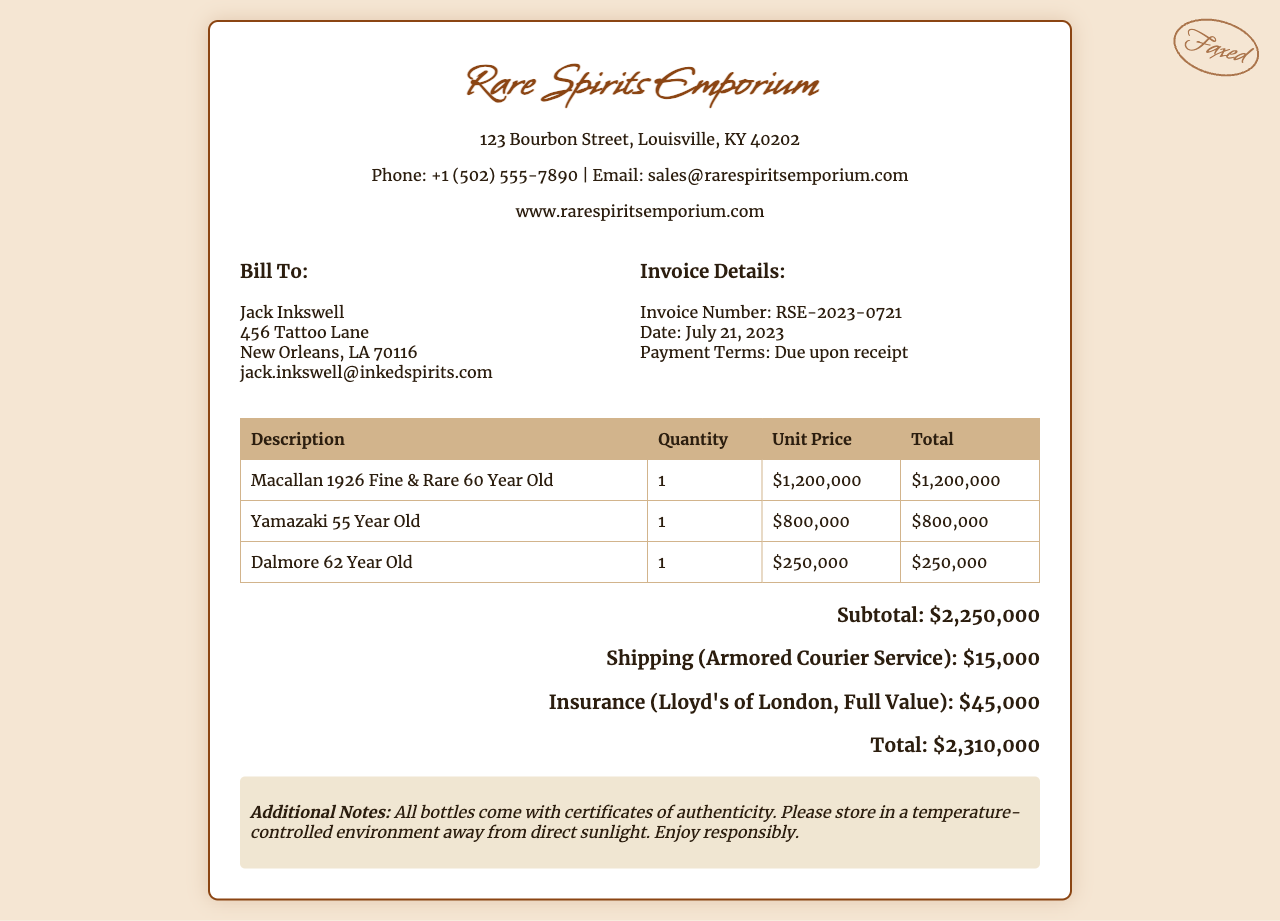What is the company name? The company name is prominently stated at the top of the invoice, identifying the seller of the rare whiskey collection.
Answer: Rare Spirits Emporium What is the invoice number? The invoice number is specified in the invoice details section, signifying the unique identifier of this transaction.
Answer: RSE-2023-0721 What is the total cost of the whiskey collection? The total cost is calculated by summing the subtotal, shipping, and insurance. It represents the final amount due for the purchase.
Answer: $2,310,000 Who is the invoice billed to? The invoice billing section displays the name and address of the buyer, indicating to whom the invoice is addressed.
Answer: Jack Inkswell What are the shipping costs? The shipping costs are itemized in the invoice's total section, detailing the expenses associated with delivery.
Answer: $15,000 How many bottles are listed in the invoice? The invoice lists the rare whiskey collection and the quantities of each bottle, showing the variety of items included in the purchase.
Answer: 3 What date is the invoice issued? The date provided in the invoice details indicates when the invoice was generated, which is crucial for payment terms.
Answer: July 21, 2023 What insurance provider is mentioned? The insurance section specifies the provider for the insurance on the shipment, which is important information for risk coverage.
Answer: Lloyd's of London What is the payment term stated in the invoice? The payment terms indicate when the payment is expected, which is essential for the buyer to know.
Answer: Due upon receipt 